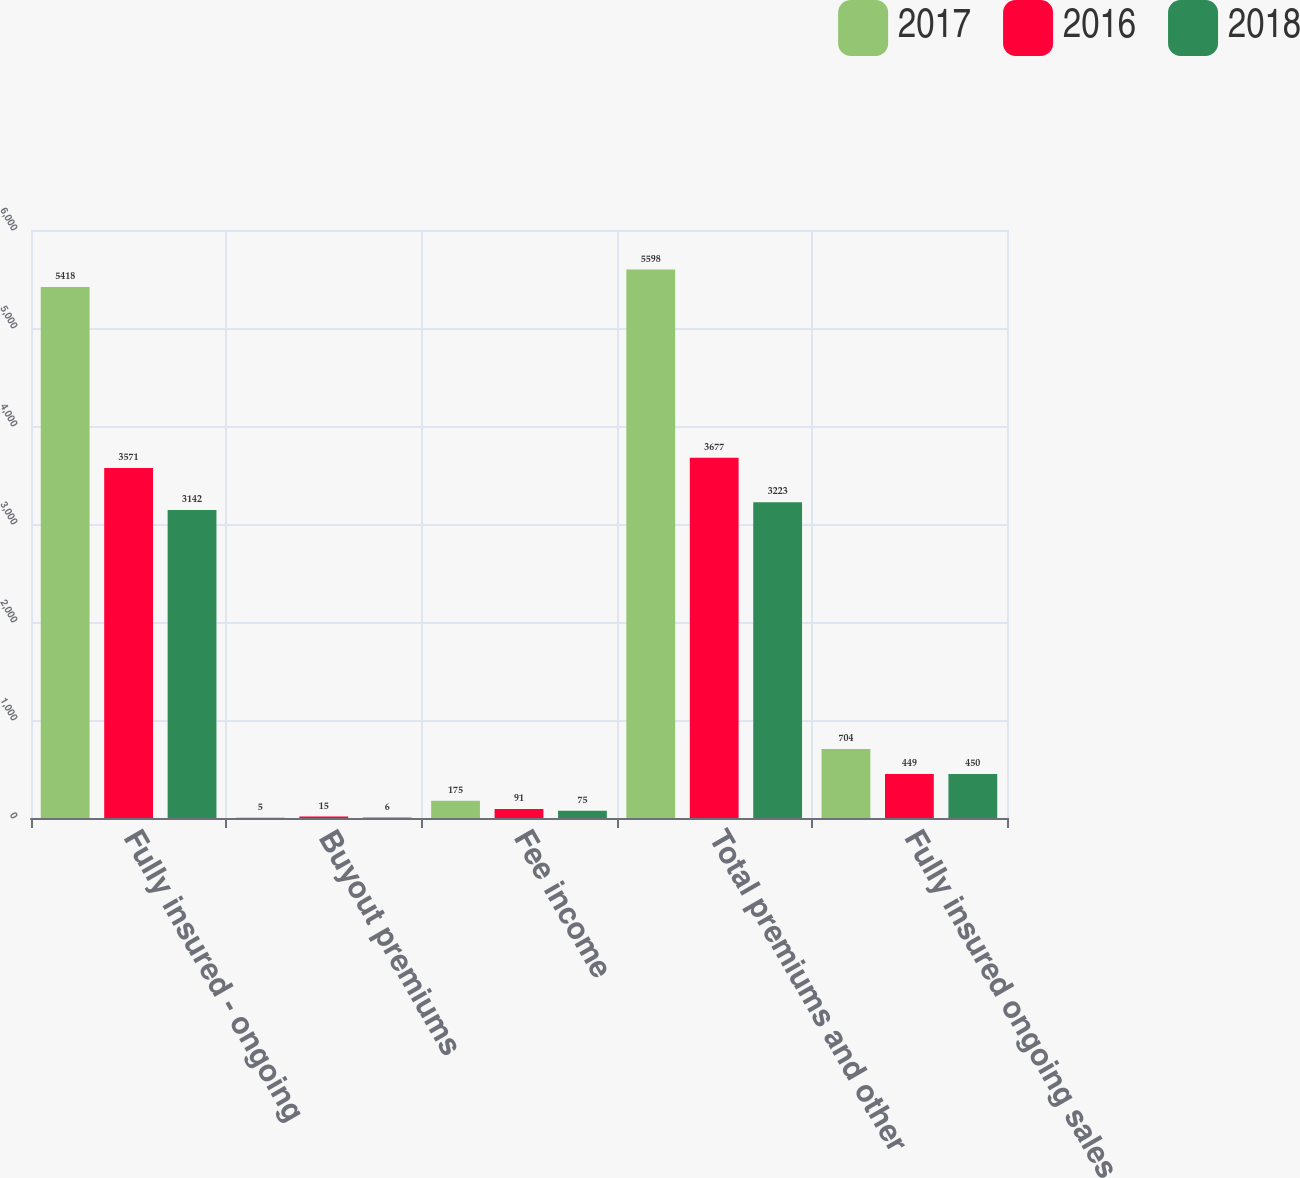Convert chart to OTSL. <chart><loc_0><loc_0><loc_500><loc_500><stacked_bar_chart><ecel><fcel>Fully insured - ongoing<fcel>Buyout premiums<fcel>Fee income<fcel>Total premiums and other<fcel>Fully insured ongoing sales<nl><fcel>2017<fcel>5418<fcel>5<fcel>175<fcel>5598<fcel>704<nl><fcel>2016<fcel>3571<fcel>15<fcel>91<fcel>3677<fcel>449<nl><fcel>2018<fcel>3142<fcel>6<fcel>75<fcel>3223<fcel>450<nl></chart> 